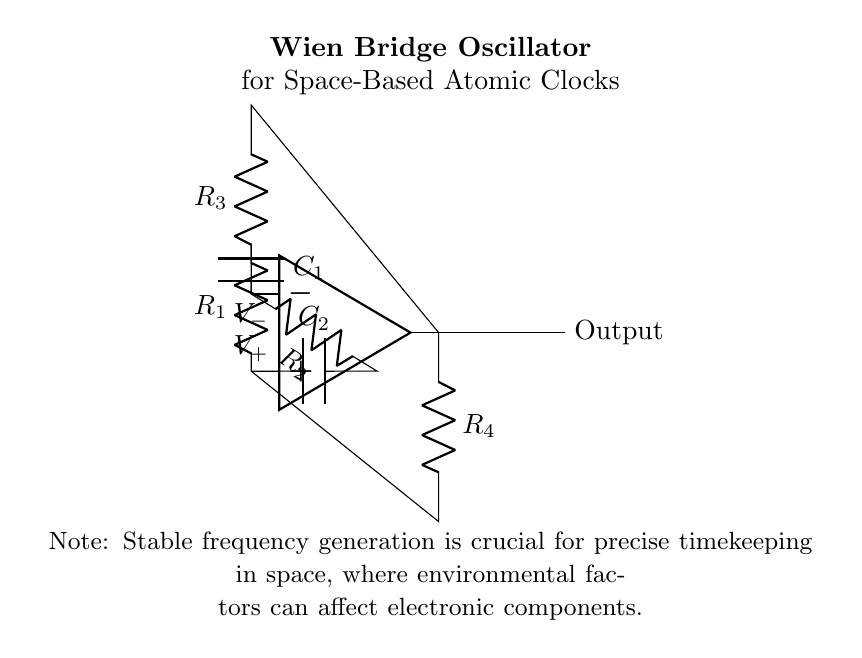What components are used in the Wien bridge oscillator? The Wien bridge oscillator circuit includes resistors (R1, R2, R3, R4) and capacitors (C1, C2), as indicated in the diagram.
Answer: Resistors and capacitors What is the purpose of the op-amp in this circuit? The op-amp amplifies the voltage difference between its input terminals and helps maintain the oscillation required for frequency generation, which is crucial in atomic clocks.
Answer: Voltage amplification What is the output of the Wien bridge oscillator? The output of the circuit is taken from the op-amp's output terminal and represents the generated oscillating signal.
Answer: Output signal How many capacitors are present in the circuit? There are two capacitors (C1 and C2) connected to the op-amp, as depicted in the diagram.
Answer: Two What role do R3 and R4 play in the circuit? R3 and R4 are feedback resistors that are critical for setting the gain of the op-amp and stabilizing the oscillation frequency in the Wien bridge oscillator.
Answer: Feedback resistors What happens if one of the resistors is altered? Changing the value of any resistor would modify the oscillation frequency of the circuit, demonstrating the interdependence of component values in determining the output frequency.
Answer: Frequency change 